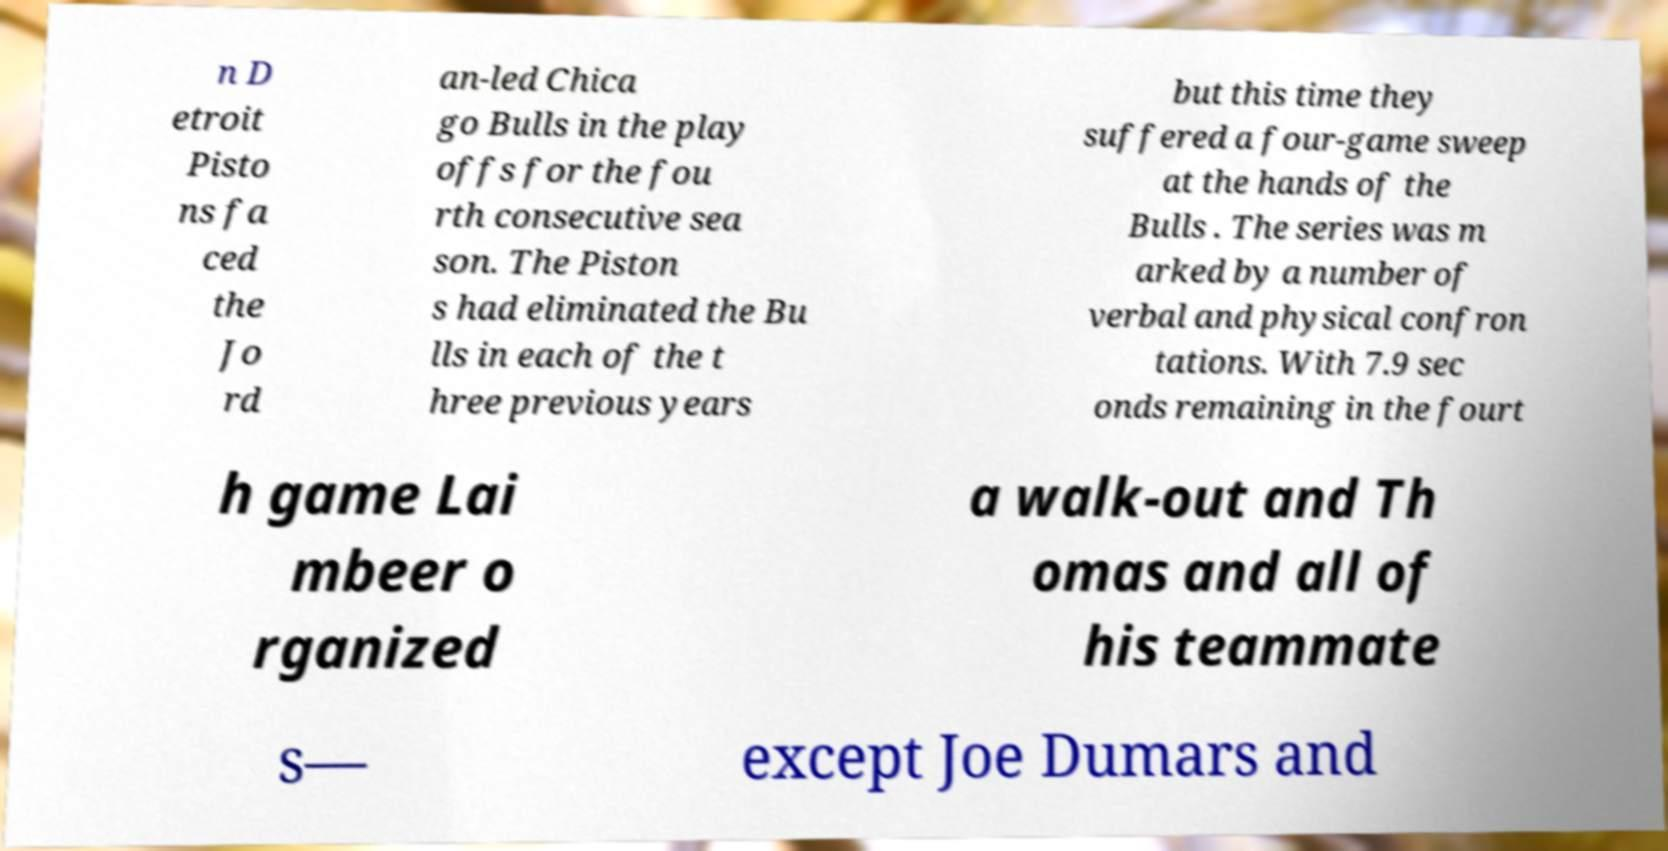Could you extract and type out the text from this image? n D etroit Pisto ns fa ced the Jo rd an-led Chica go Bulls in the play offs for the fou rth consecutive sea son. The Piston s had eliminated the Bu lls in each of the t hree previous years but this time they suffered a four-game sweep at the hands of the Bulls . The series was m arked by a number of verbal and physical confron tations. With 7.9 sec onds remaining in the fourt h game Lai mbeer o rganized a walk-out and Th omas and all of his teammate s— except Joe Dumars and 